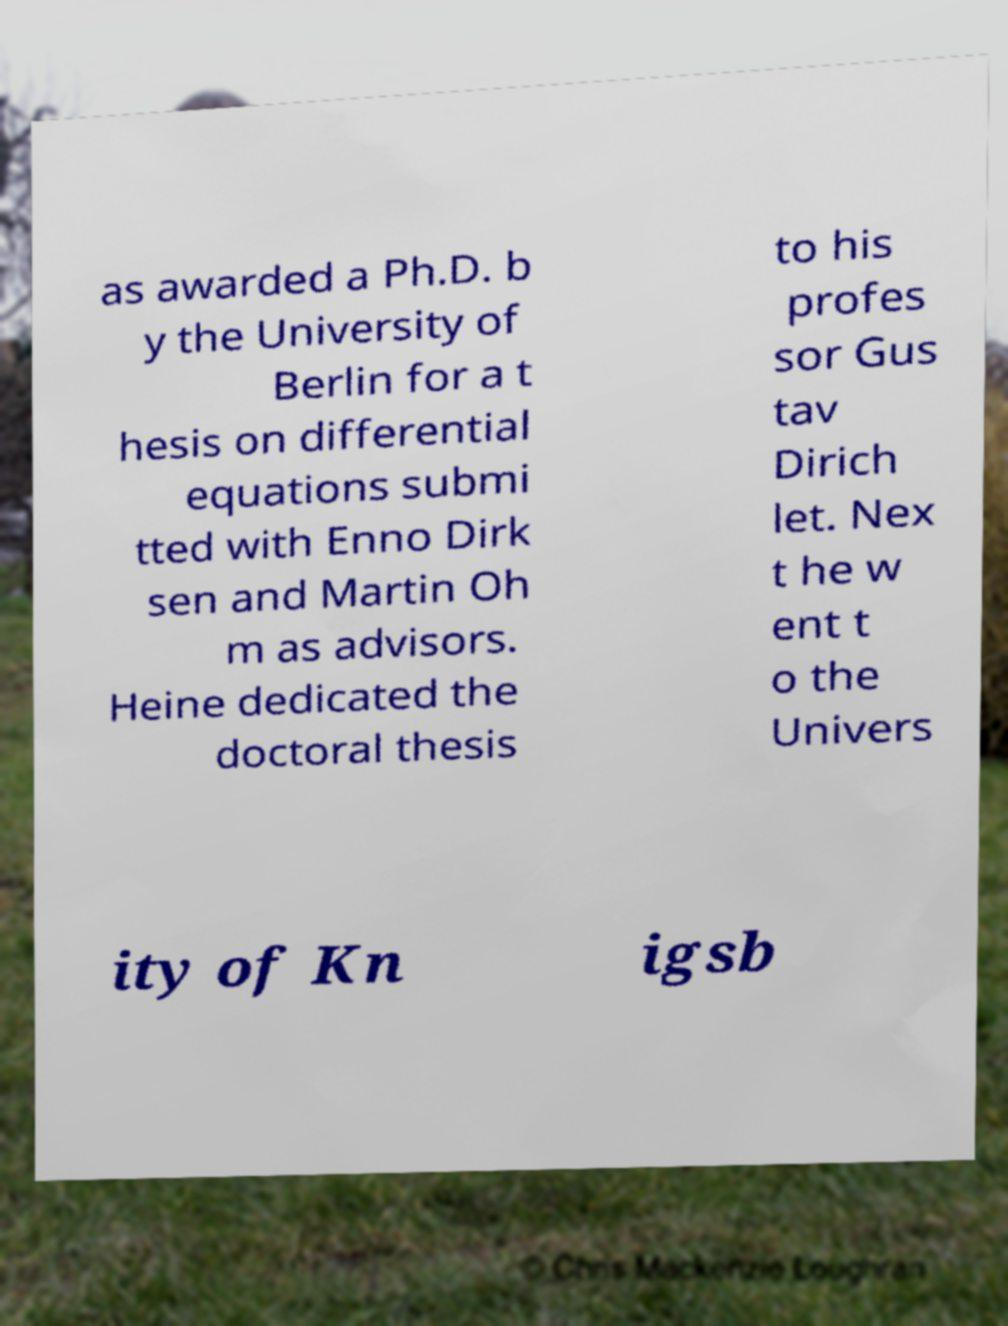Can you accurately transcribe the text from the provided image for me? as awarded a Ph.D. b y the University of Berlin for a t hesis on differential equations submi tted with Enno Dirk sen and Martin Oh m as advisors. Heine dedicated the doctoral thesis to his profes sor Gus tav Dirich let. Nex t he w ent t o the Univers ity of Kn igsb 